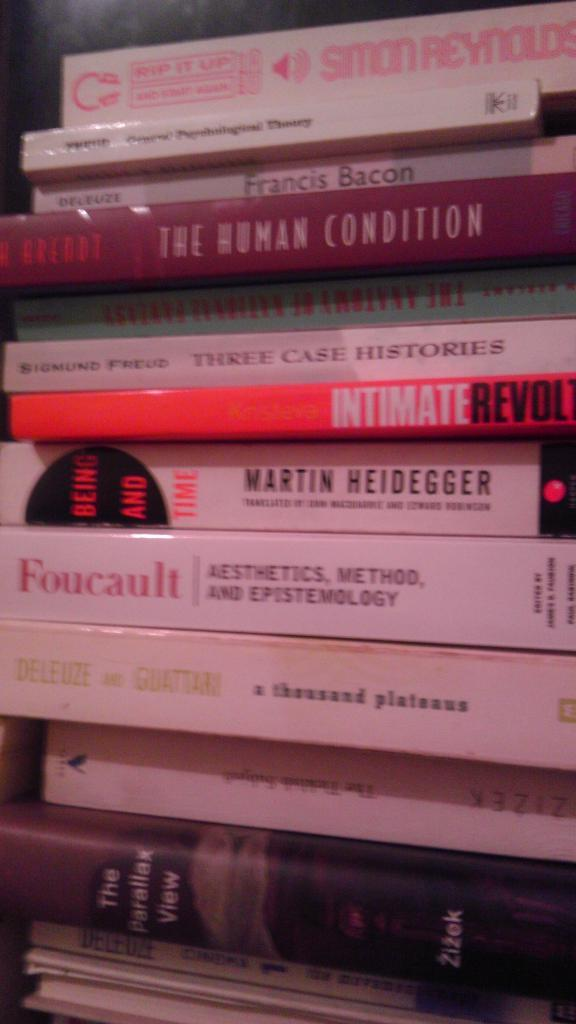<image>
Write a terse but informative summary of the picture. A book titled The Human Condition is in a stack of books. 